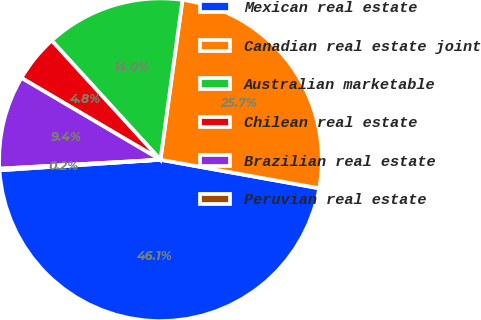Convert chart. <chart><loc_0><loc_0><loc_500><loc_500><pie_chart><fcel>Mexican real estate<fcel>Canadian real estate joint<fcel>Australian marketable<fcel>Chilean real estate<fcel>Brazilian real estate<fcel>Peruvian real estate<nl><fcel>46.12%<fcel>25.65%<fcel>13.95%<fcel>4.76%<fcel>9.35%<fcel>0.16%<nl></chart> 